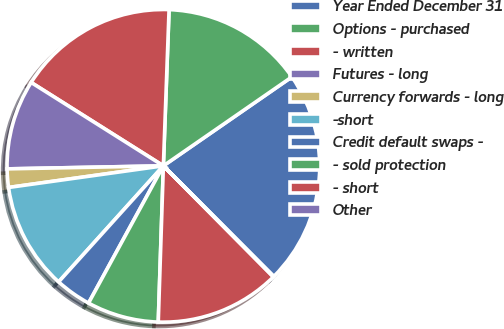<chart> <loc_0><loc_0><loc_500><loc_500><pie_chart><fcel>Year Ended December 31<fcel>Options - purchased<fcel>- written<fcel>Futures - long<fcel>Currency forwards - long<fcel>-short<fcel>Credit default swaps -<fcel>- sold protection<fcel>- short<fcel>Other<nl><fcel>22.14%<fcel>14.78%<fcel>16.62%<fcel>9.26%<fcel>1.9%<fcel>11.1%<fcel>3.74%<fcel>7.42%<fcel>12.94%<fcel>0.06%<nl></chart> 